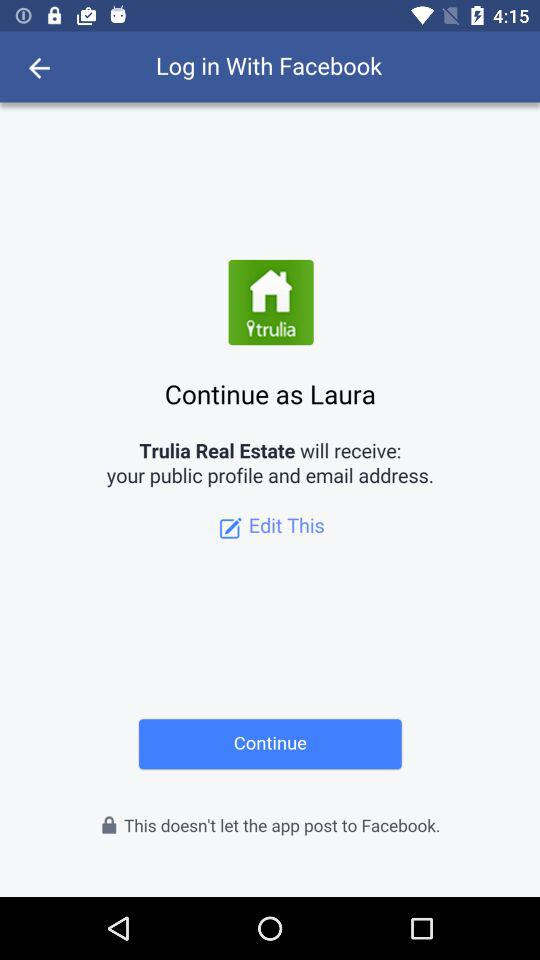What application is asking for permission? The application that is asking for permission is "Trulia Real Estate". 